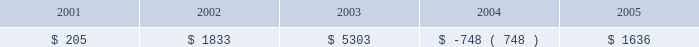For fiscal year 2005 , the effective tax rate includes the impact of $ 11.6 million tax expense associated with repatriation of approximately $ 185.0 million of foreign earnings under the provisions of the american jobs creation act of 2004 .
For fiscal year 2004 , the effective tax rate reflects the tax benefit derived from higher earnings in low-tax jurisdictions .
During fiscal year 2006 , primarily due to a tax accounting method change , there was a decrease of $ 83.2 million in the current deferred tax assets , and a corresponding increase in non-current deferred tax assets .
In the third quarter of fiscal year 2006 , we changed our tax accounting method on our tax return for fiscal year 2005 with respect to the current portion of deferred revenue to follow the recognition of revenue under u.s .
Generally accepted accounting principles .
This accounting method change , as well as other adjustments made to our taxable income upon the filing of the fiscal year 2005 tax return , resulted in an increase in our operating loss ( nol ) carryforwards .
In may 2006 , the tax increase prevention and reconciliation act of 2005 was enacted , which provides a three-year exception to current u.s .
Taxation of certain foreign intercompany income .
This provision will first apply to synopsys in fiscal year 2007 .
Management estimates that had such provisions been applied for fiscal 2006 , our income tax expense would have been reduced by approximately $ 3 million .
In december 2006 , the tax relief and health care act of 2006 was enacted , which retroactively extended the research and development credit from january 1 , 2006 .
As a result , we will record an expected increase in our fiscal 2006 research and development credit of between $ 1.5 million and $ 1.8 million in the first quarter of fiscal 2007 .
Revision of prior year financial statements .
As part of our remediation of the material weakness in internal control over financial reporting identified in fiscal 2005 relating to accounting for income taxes we implemented additional internal control and review procedures .
Through such procedures , in the fourth quarter of fiscal 2006 , we identified four errors totaling $ 8.2 million which affected our income tax provision in fiscal years 2001 through 2005 .
We concluded that these errors were not material to any prior year financial statements .
Although the errors are not material to prior periods , we elected to revise prior year financial statements to correct such errors .
The fiscal periods in which the errors originated , and the resulting change in provision ( benefit ) for income taxes for each year , are reflected in the table : year ended october 31 ( in thousands ) .
The errors were as follows : ( 1 ) synopsys inadvertently provided a $ 1.4 million tax benefit for the write- off of goodwill relating to an acquisition in fiscal 2002 ; ( 2 ) synopsys did not accrue interest and penalties for certain foreign tax contingency items in the amount of $ 3.2 million ; ( 3 ) synopsys made certain computational errors relating to foreign dividends of $ 2.3 million ; and ( 4 ) synopsys did not record a valuation allowance relating to certain state tax credits of $ 1.3 million .
As result of this revision , non-current deferred tax assets decreased by $ 8.1 million and current taxes payable increased by $ 0.2 million .
Retained earnings decreased by $ 8.2 million and additional paid in capital decreased by $ 0.1 million .
See item 9a .
Controls and procedures for a further discussion of our remediation of the material weakness .
Tax effects of stock awards .
In november 2005 , fasb issued a staff position ( fsp ) on fas 123 ( r ) -3 , transition election related to accounting for the tax effects of share-based payment awards .
Effective upon issuance , this fsp describes an alternative transition method for calculating the tax effects of share-based compensation pursuant to sfas 123 ( r ) .
The alternative transition method includes simplified methods to establish the beginning balance of the additional paid-in capital pool ( apic pool ) related to the tax effects of employee stock based compensation , and to determine the subsequent impact on the apic pool and the statement of cash flows of the tax effects of employee share-based compensation .
What is the variation observed in the resulting change in provision for income taxes caused by errors during 2002 and 2001? 
Rationale: it is the difference between those values .
Computations: (1833 - 205)
Answer: 1628.0. 